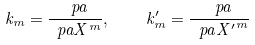<formula> <loc_0><loc_0><loc_500><loc_500>k _ { m } = \frac { \ p a } { \ p a X ^ { m } } , \quad k ^ { \prime } _ { m } = \frac { \ p a } { \ p a { X ^ { \prime } } ^ { m } }</formula> 